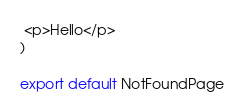Convert code to text. <code><loc_0><loc_0><loc_500><loc_500><_JavaScript_> <p>Hello</p>
)

export default NotFoundPage
</code> 